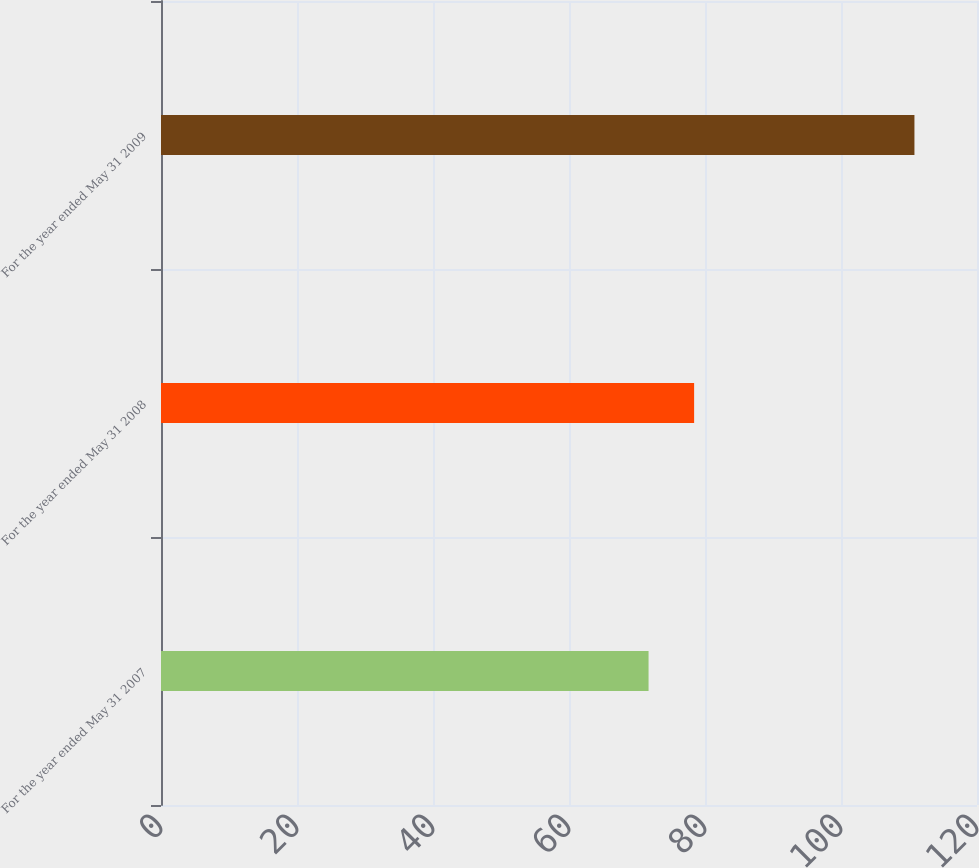Convert chart to OTSL. <chart><loc_0><loc_0><loc_500><loc_500><bar_chart><fcel>For the year ended May 31 2007<fcel>For the year ended May 31 2008<fcel>For the year ended May 31 2009<nl><fcel>71.7<fcel>78.4<fcel>110.8<nl></chart> 